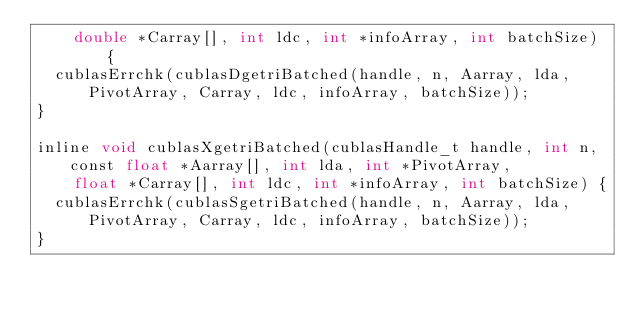<code> <loc_0><loc_0><loc_500><loc_500><_Cuda_>		double *Carray[], int ldc, int *infoArray, int batchSize) {
	cublasErrchk(cublasDgetriBatched(handle, n, Aarray, lda, PivotArray, Carray, ldc, infoArray, batchSize));
}

inline void cublasXgetriBatched(cublasHandle_t handle, int n, const float *Aarray[], int lda, int *PivotArray,
		float *Carray[], int ldc, int *infoArray, int batchSize) {
	cublasErrchk(cublasSgetriBatched(handle, n, Aarray, lda, PivotArray, Carray, ldc, infoArray, batchSize));
}
</code> 